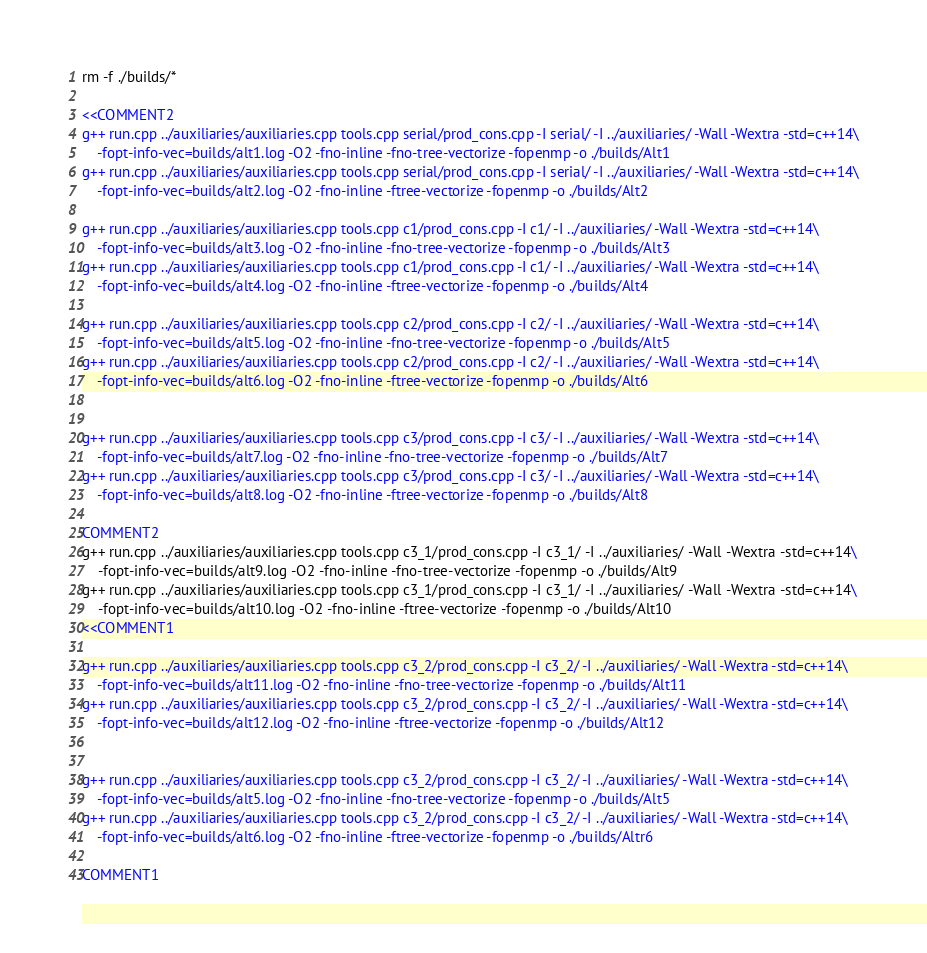<code> <loc_0><loc_0><loc_500><loc_500><_Bash_>rm -f ./builds/*

<<COMMENT2
g++ run.cpp ../auxiliaries/auxiliaries.cpp tools.cpp serial/prod_cons.cpp -I serial/ -I ../auxiliaries/ -Wall -Wextra -std=c++14\
    -fopt-info-vec=builds/alt1.log -O2 -fno-inline -fno-tree-vectorize -fopenmp -o ./builds/Alt1
g++ run.cpp ../auxiliaries/auxiliaries.cpp tools.cpp serial/prod_cons.cpp -I serial/ -I ../auxiliaries/ -Wall -Wextra -std=c++14\
    -fopt-info-vec=builds/alt2.log -O2 -fno-inline -ftree-vectorize -fopenmp -o ./builds/Alt2

g++ run.cpp ../auxiliaries/auxiliaries.cpp tools.cpp c1/prod_cons.cpp -I c1/ -I ../auxiliaries/ -Wall -Wextra -std=c++14\
    -fopt-info-vec=builds/alt3.log -O2 -fno-inline -fno-tree-vectorize -fopenmp -o ./builds/Alt3
g++ run.cpp ../auxiliaries/auxiliaries.cpp tools.cpp c1/prod_cons.cpp -I c1/ -I ../auxiliaries/ -Wall -Wextra -std=c++14\
    -fopt-info-vec=builds/alt4.log -O2 -fno-inline -ftree-vectorize -fopenmp -o ./builds/Alt4

g++ run.cpp ../auxiliaries/auxiliaries.cpp tools.cpp c2/prod_cons.cpp -I c2/ -I ../auxiliaries/ -Wall -Wextra -std=c++14\
    -fopt-info-vec=builds/alt5.log -O2 -fno-inline -fno-tree-vectorize -fopenmp -o ./builds/Alt5
g++ run.cpp ../auxiliaries/auxiliaries.cpp tools.cpp c2/prod_cons.cpp -I c2/ -I ../auxiliaries/ -Wall -Wextra -std=c++14\
    -fopt-info-vec=builds/alt6.log -O2 -fno-inline -ftree-vectorize -fopenmp -o ./builds/Alt6


g++ run.cpp ../auxiliaries/auxiliaries.cpp tools.cpp c3/prod_cons.cpp -I c3/ -I ../auxiliaries/ -Wall -Wextra -std=c++14\
    -fopt-info-vec=builds/alt7.log -O2 -fno-inline -fno-tree-vectorize -fopenmp -o ./builds/Alt7
g++ run.cpp ../auxiliaries/auxiliaries.cpp tools.cpp c3/prod_cons.cpp -I c3/ -I ../auxiliaries/ -Wall -Wextra -std=c++14\
    -fopt-info-vec=builds/alt8.log -O2 -fno-inline -ftree-vectorize -fopenmp -o ./builds/Alt8

COMMENT2
g++ run.cpp ../auxiliaries/auxiliaries.cpp tools.cpp c3_1/prod_cons.cpp -I c3_1/ -I ../auxiliaries/ -Wall -Wextra -std=c++14\
    -fopt-info-vec=builds/alt9.log -O2 -fno-inline -fno-tree-vectorize -fopenmp -o ./builds/Alt9
g++ run.cpp ../auxiliaries/auxiliaries.cpp tools.cpp c3_1/prod_cons.cpp -I c3_1/ -I ../auxiliaries/ -Wall -Wextra -std=c++14\
    -fopt-info-vec=builds/alt10.log -O2 -fno-inline -ftree-vectorize -fopenmp -o ./builds/Alt10
<<COMMENT1

g++ run.cpp ../auxiliaries/auxiliaries.cpp tools.cpp c3_2/prod_cons.cpp -I c3_2/ -I ../auxiliaries/ -Wall -Wextra -std=c++14\
    -fopt-info-vec=builds/alt11.log -O2 -fno-inline -fno-tree-vectorize -fopenmp -o ./builds/Alt11
g++ run.cpp ../auxiliaries/auxiliaries.cpp tools.cpp c3_2/prod_cons.cpp -I c3_2/ -I ../auxiliaries/ -Wall -Wextra -std=c++14\
    -fopt-info-vec=builds/alt12.log -O2 -fno-inline -ftree-vectorize -fopenmp -o ./builds/Alt12


g++ run.cpp ../auxiliaries/auxiliaries.cpp tools.cpp c3_2/prod_cons.cpp -I c3_2/ -I ../auxiliaries/ -Wall -Wextra -std=c++14\
    -fopt-info-vec=builds/alt5.log -O2 -fno-inline -fno-tree-vectorize -fopenmp -o ./builds/Alt5
g++ run.cpp ../auxiliaries/auxiliaries.cpp tools.cpp c3_2/prod_cons.cpp -I c3_2/ -I ../auxiliaries/ -Wall -Wextra -std=c++14\
    -fopt-info-vec=builds/alt6.log -O2 -fno-inline -ftree-vectorize -fopenmp -o ./builds/Altr6

COMMENT1
</code> 